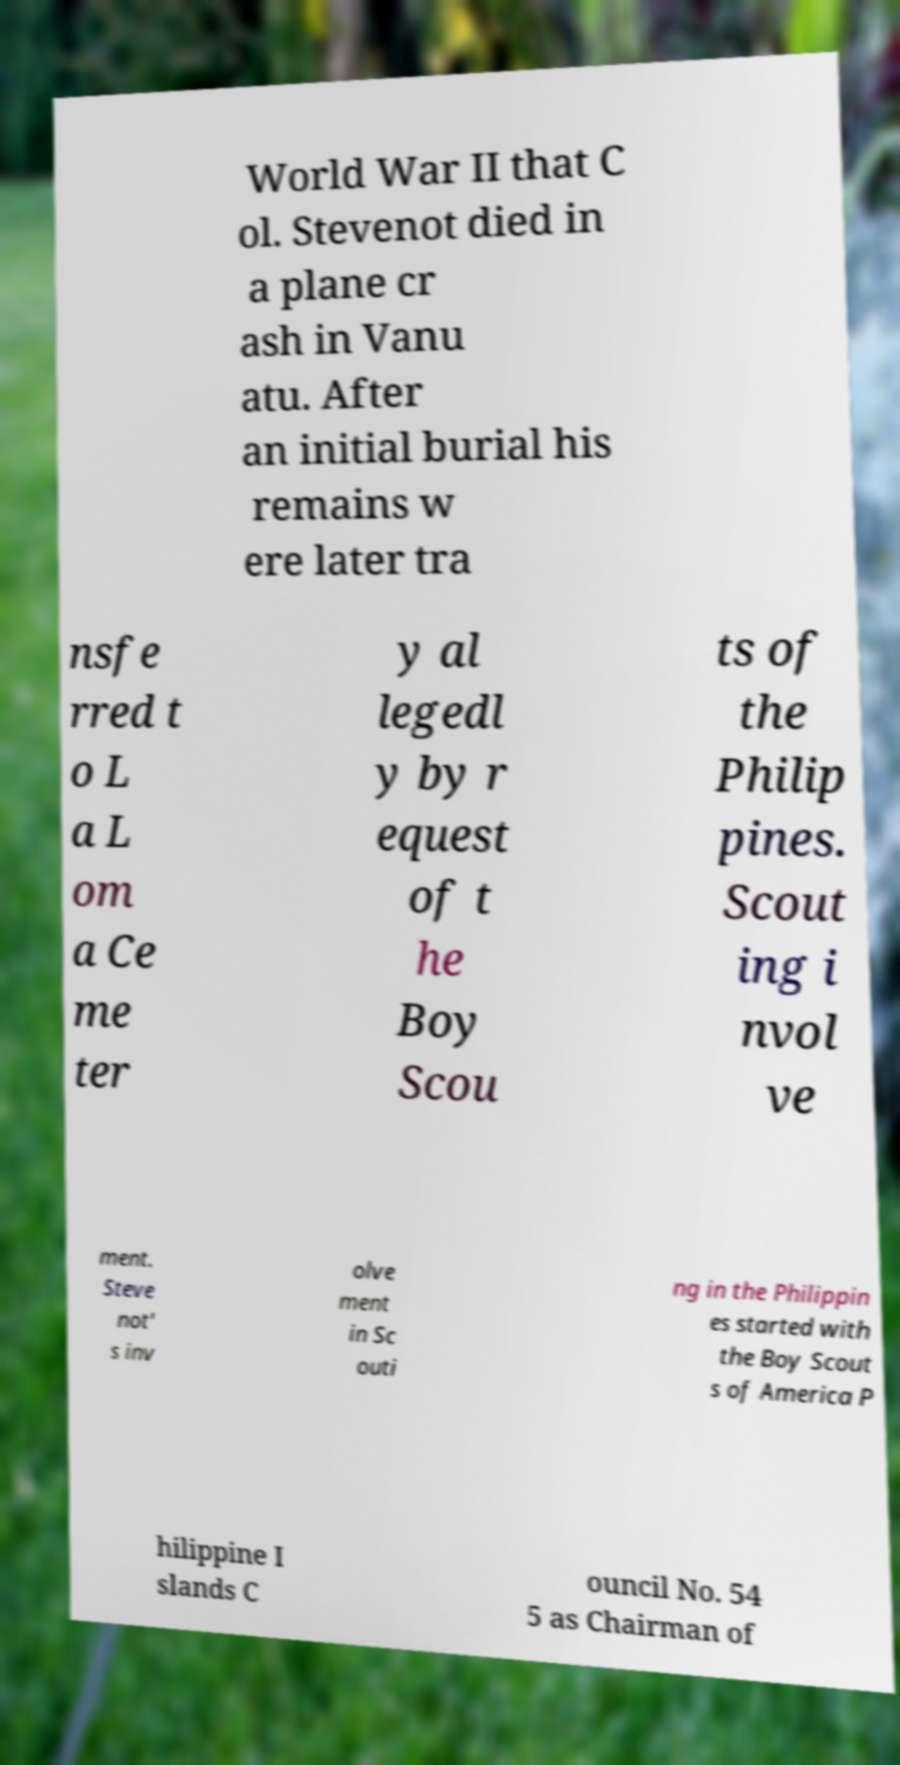Please read and relay the text visible in this image. What does it say? World War II that C ol. Stevenot died in a plane cr ash in Vanu atu. After an initial burial his remains w ere later tra nsfe rred t o L a L om a Ce me ter y al legedl y by r equest of t he Boy Scou ts of the Philip pines. Scout ing i nvol ve ment. Steve not' s inv olve ment in Sc outi ng in the Philippin es started with the Boy Scout s of America P hilippine I slands C ouncil No. 54 5 as Chairman of 